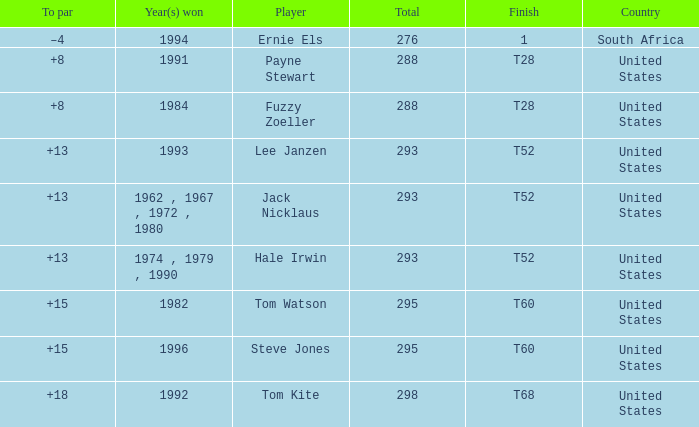What year did player steve jones, who had a t60 finish, win? 1996.0. 